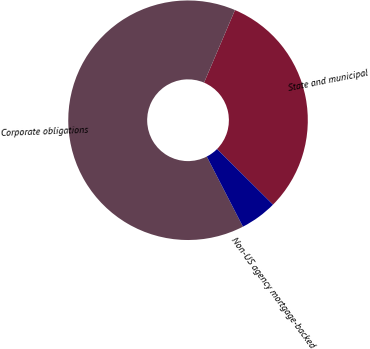Convert chart. <chart><loc_0><loc_0><loc_500><loc_500><pie_chart><fcel>State and municipal<fcel>Corporate obligations<fcel>Non-US agency mortgage-backed<nl><fcel>31.04%<fcel>63.99%<fcel>4.97%<nl></chart> 